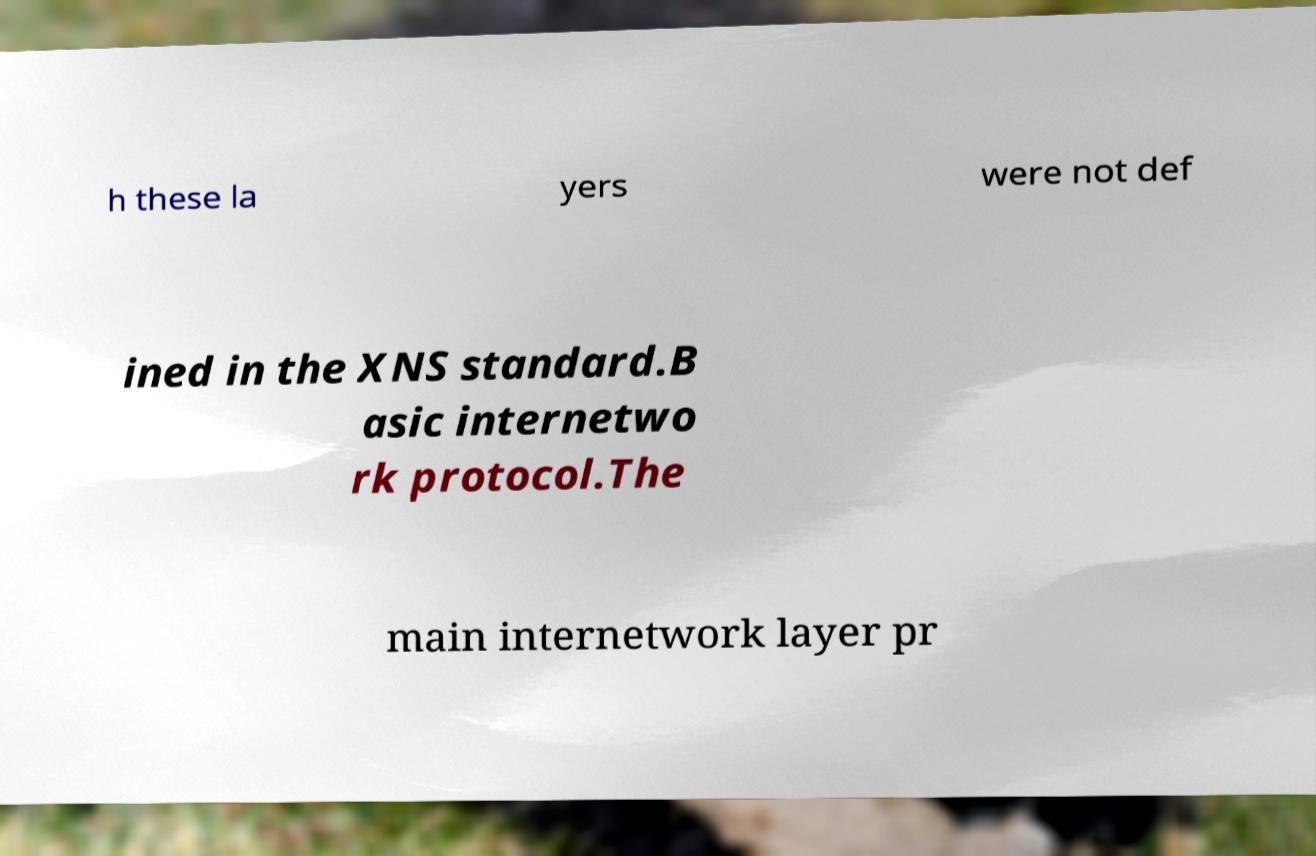Please read and relay the text visible in this image. What does it say? h these la yers were not def ined in the XNS standard.B asic internetwo rk protocol.The main internetwork layer pr 